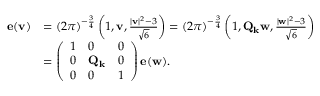Convert formula to latex. <formula><loc_0><loc_0><loc_500><loc_500>\begin{array} { r l } { e ( v ) } & { = ( 2 \pi ) ^ { - \frac { 3 } { 4 } } \left ( 1 , v , \frac { | v | ^ { 2 } - 3 } { \sqrt { 6 } } \right ) = ( 2 \pi ) ^ { - \frac { 3 } { 4 } } \left ( 1 , Q _ { k } w , \frac { | w | ^ { 2 } - 3 } { \sqrt { 6 } } \right ) } \\ & { = \left ( \begin{array} { l l l } { 1 } & { 0 } & { 0 } \\ { 0 } & { Q _ { k } } & { 0 } \\ { 0 } & { 0 } & { 1 } \end{array} \right ) e ( w ) . } \end{array}</formula> 